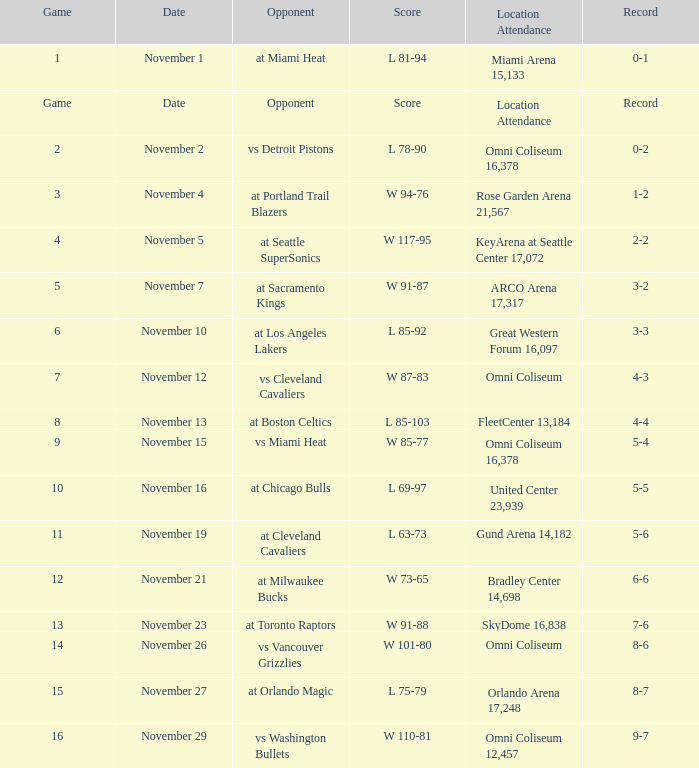Would you be able to parse every entry in this table? {'header': ['Game', 'Date', 'Opponent', 'Score', 'Location Attendance', 'Record'], 'rows': [['1', 'November 1', 'at Miami Heat', 'L 81-94', 'Miami Arena 15,133', '0-1'], ['Game', 'Date', 'Opponent', 'Score', 'Location Attendance', 'Record'], ['2', 'November 2', 'vs Detroit Pistons', 'L 78-90', 'Omni Coliseum 16,378', '0-2'], ['3', 'November 4', 'at Portland Trail Blazers', 'W 94-76', 'Rose Garden Arena 21,567', '1-2'], ['4', 'November 5', 'at Seattle SuperSonics', 'W 117-95', 'KeyArena at Seattle Center 17,072', '2-2'], ['5', 'November 7', 'at Sacramento Kings', 'W 91-87', 'ARCO Arena 17,317', '3-2'], ['6', 'November 10', 'at Los Angeles Lakers', 'L 85-92', 'Great Western Forum 16,097', '3-3'], ['7', 'November 12', 'vs Cleveland Cavaliers', 'W 87-83', 'Omni Coliseum', '4-3'], ['8', 'November 13', 'at Boston Celtics', 'L 85-103', 'FleetCenter 13,184', '4-4'], ['9', 'November 15', 'vs Miami Heat', 'W 85-77', 'Omni Coliseum 16,378', '5-4'], ['10', 'November 16', 'at Chicago Bulls', 'L 69-97', 'United Center 23,939', '5-5'], ['11', 'November 19', 'at Cleveland Cavaliers', 'L 63-73', 'Gund Arena 14,182', '5-6'], ['12', 'November 21', 'at Milwaukee Bucks', 'W 73-65', 'Bradley Center 14,698', '6-6'], ['13', 'November 23', 'at Toronto Raptors', 'W 91-88', 'SkyDome 16,838', '7-6'], ['14', 'November 26', 'vs Vancouver Grizzlies', 'W 101-80', 'Omni Coliseum', '8-6'], ['15', 'November 27', 'at Orlando Magic', 'L 75-79', 'Orlando Arena 17,248', '8-7'], ['16', 'November 29', 'vs Washington Bullets', 'W 110-81', 'Omni Coliseum 12,457', '9-7']]} Who was their opponent in game 4? At seattle supersonics. 